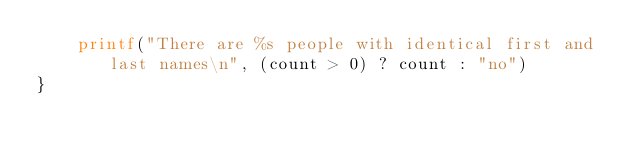<code> <loc_0><loc_0><loc_500><loc_500><_Awk_>    printf("There are %s people with identical first and last names\n", (count > 0) ? count : "no")
}
</code> 